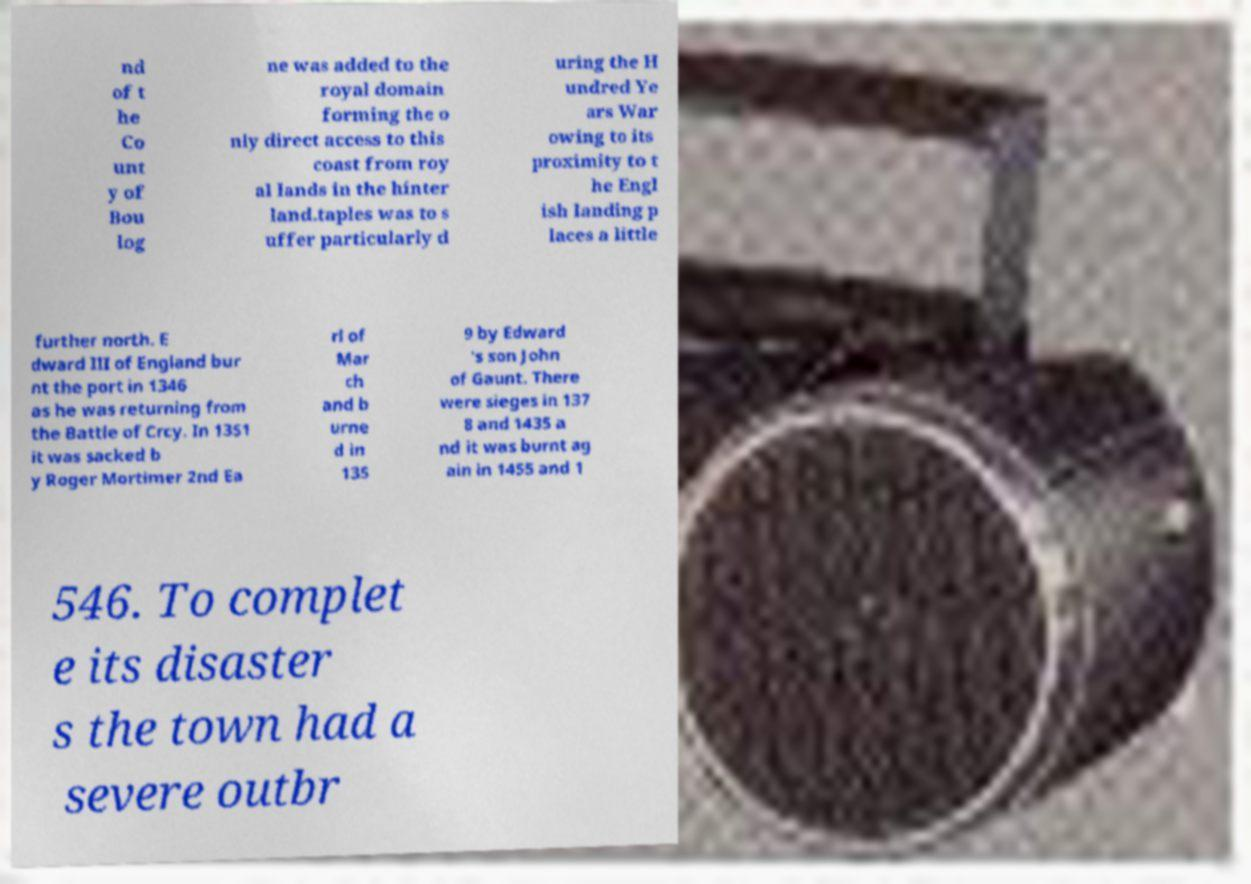Please read and relay the text visible in this image. What does it say? nd of t he Co unt y of Bou log ne was added to the royal domain forming the o nly direct access to this coast from roy al lands in the hinter land.taples was to s uffer particularly d uring the H undred Ye ars War owing to its proximity to t he Engl ish landing p laces a little further north. E dward III of England bur nt the port in 1346 as he was returning from the Battle of Crcy. In 1351 it was sacked b y Roger Mortimer 2nd Ea rl of Mar ch and b urne d in 135 9 by Edward 's son John of Gaunt. There were sieges in 137 8 and 1435 a nd it was burnt ag ain in 1455 and 1 546. To complet e its disaster s the town had a severe outbr 